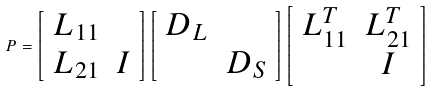Convert formula to latex. <formula><loc_0><loc_0><loc_500><loc_500>P = \left [ \begin{array} { c c c c } L _ { 1 1 } & \\ L _ { 2 1 } & I \\ \end{array} \right ] \left [ \begin{array} { c c c c } D _ { L } & \\ & D _ { S } \\ \end{array} \right ] \left [ \begin{array} { c c c c } L _ { 1 1 } ^ { T } & L _ { 2 1 } ^ { T } \\ & I \\ \end{array} \right ]</formula> 